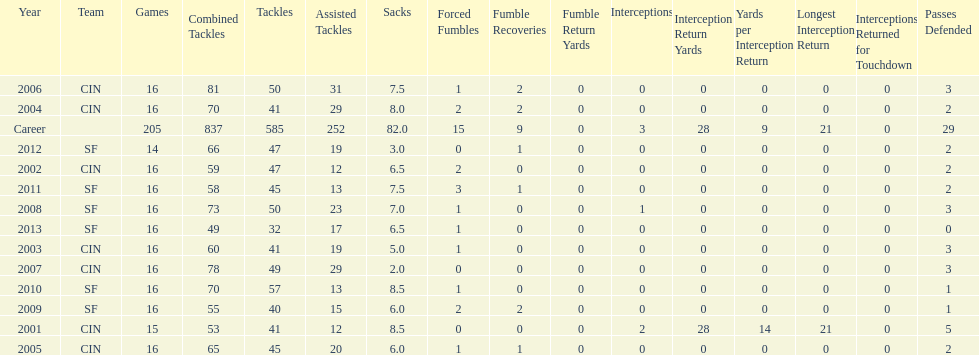What was the number of combined tackles in 2010? 70. 